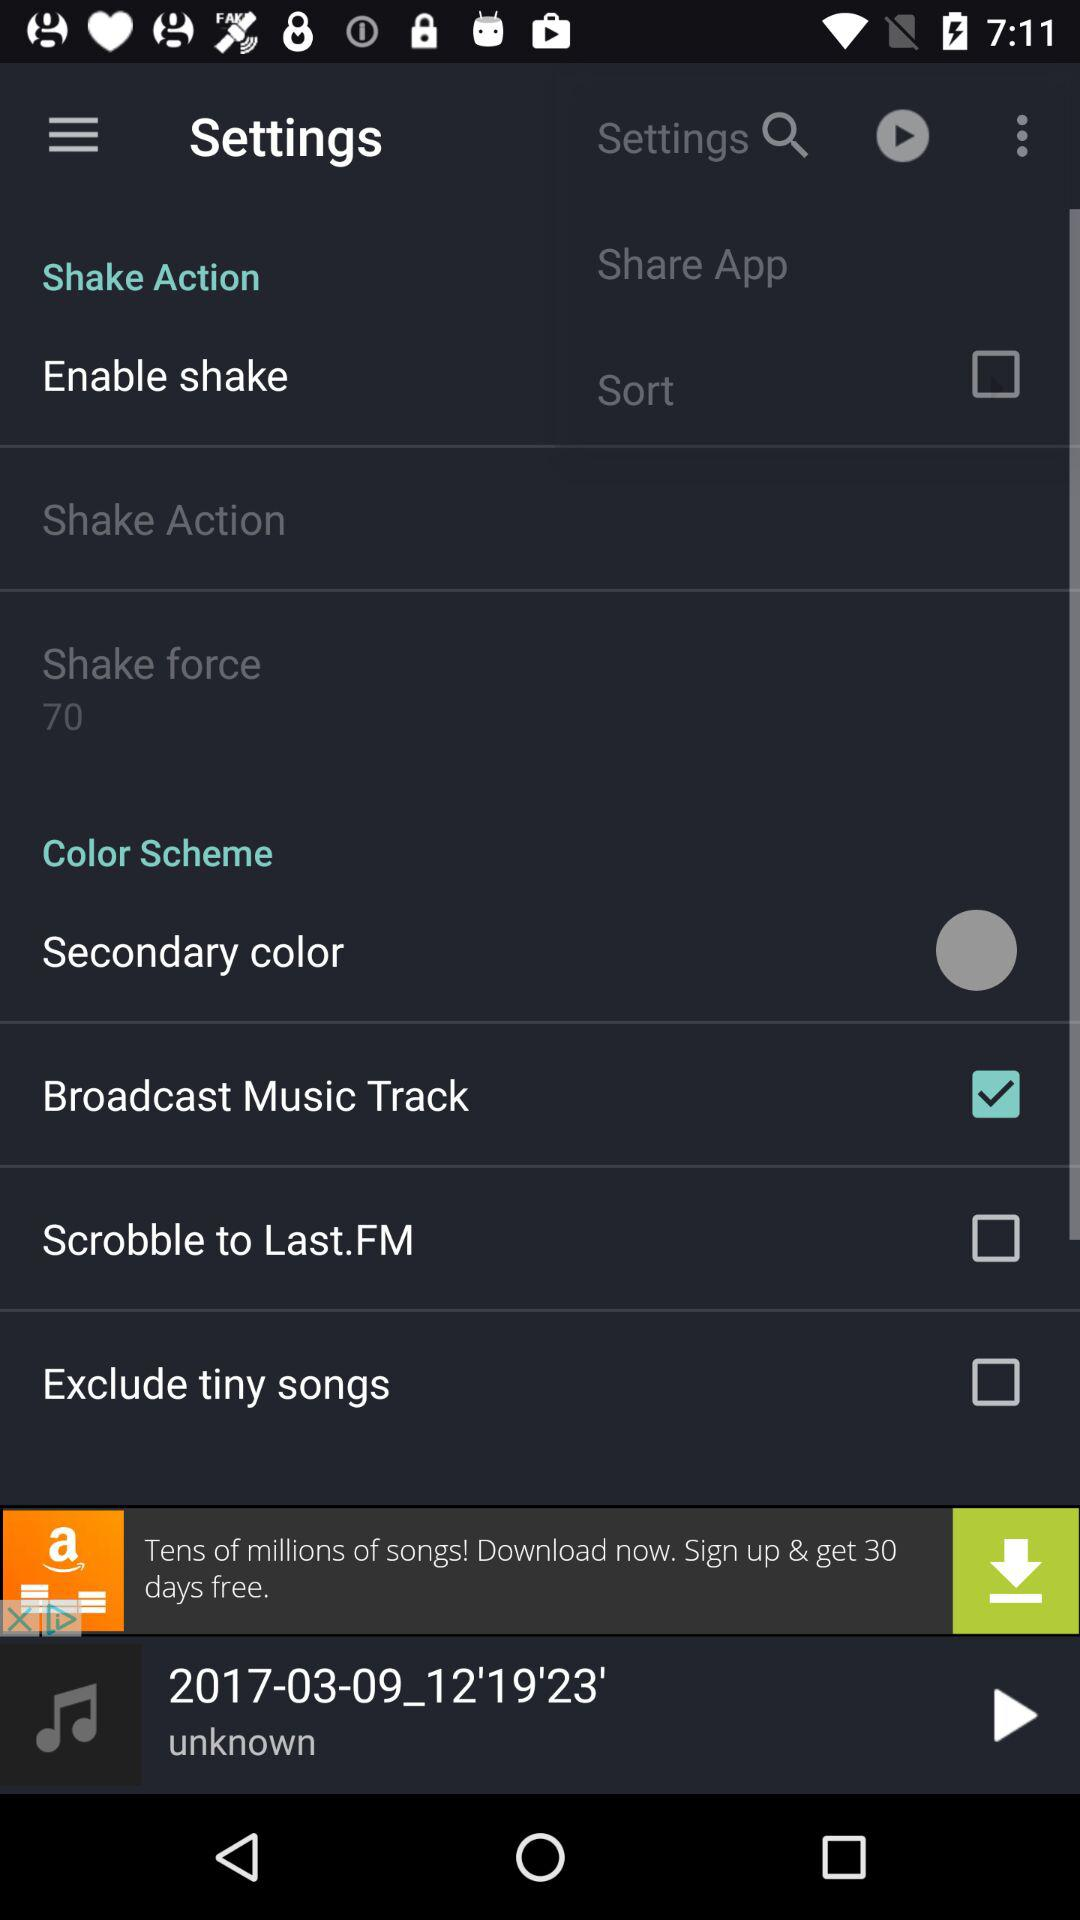What is the number of the shake force? The number is 70. 